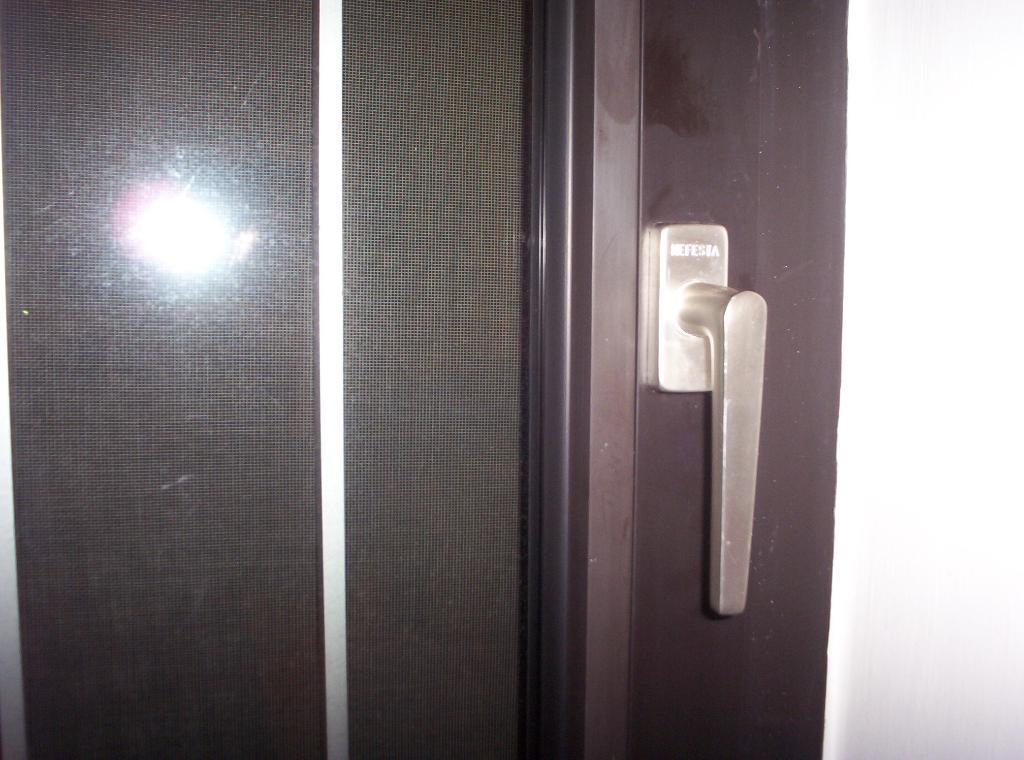Please provide a concise description of this image. In this image I can see a door handle, which is attached to the wooden door. This looks like a reflection of the light. 